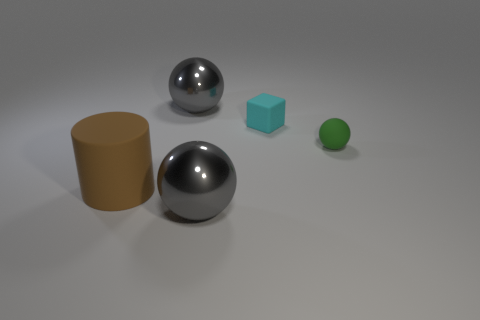How many metal things are there?
Your response must be concise. 2. Do the gray metallic object that is behind the cylinder and the tiny green thing have the same size?
Provide a succinct answer. No. What number of metal things are either gray objects or cyan cylinders?
Your answer should be very brief. 2. There is a ball to the right of the small cyan matte object; what number of big metal objects are in front of it?
Your answer should be compact. 1. What is the shape of the matte object that is both in front of the cyan block and behind the brown thing?
Provide a short and direct response. Sphere. What material is the green ball that is in front of the shiny sphere behind the gray shiny sphere in front of the tiny green rubber object made of?
Keep it short and to the point. Rubber. What material is the green ball?
Ensure brevity in your answer.  Rubber. Do the brown cylinder and the small object to the right of the small block have the same material?
Give a very brief answer. Yes. The object that is to the left of the gray shiny ball that is behind the green matte ball is what color?
Offer a very short reply. Brown. There is a rubber object that is on the right side of the brown thing and to the left of the tiny rubber ball; what size is it?
Your answer should be compact. Small. 